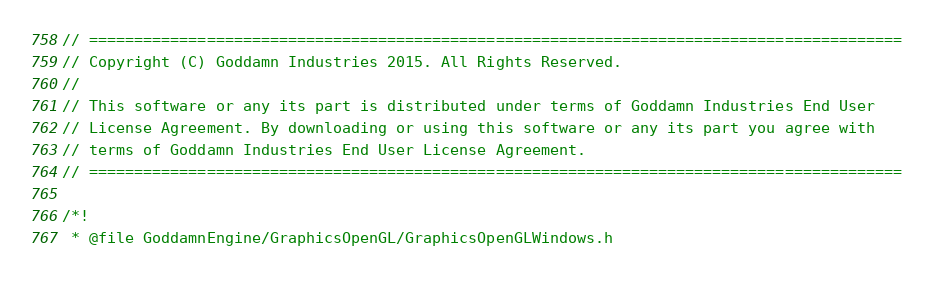<code> <loc_0><loc_0><loc_500><loc_500><_C_>// ==========================================================================================
// Copyright (C) Goddamn Industries 2015. All Rights Reserved.
// 
// This software or any its part is distributed under terms of Goddamn Industries End User
// License Agreement. By downloading or using this software or any its part you agree with 
// terms of Goddamn Industries End User License Agreement.
// ==========================================================================================

/*!
 * @file GoddamnEngine/GraphicsOpenGL/GraphicsOpenGLWindows.h</code> 